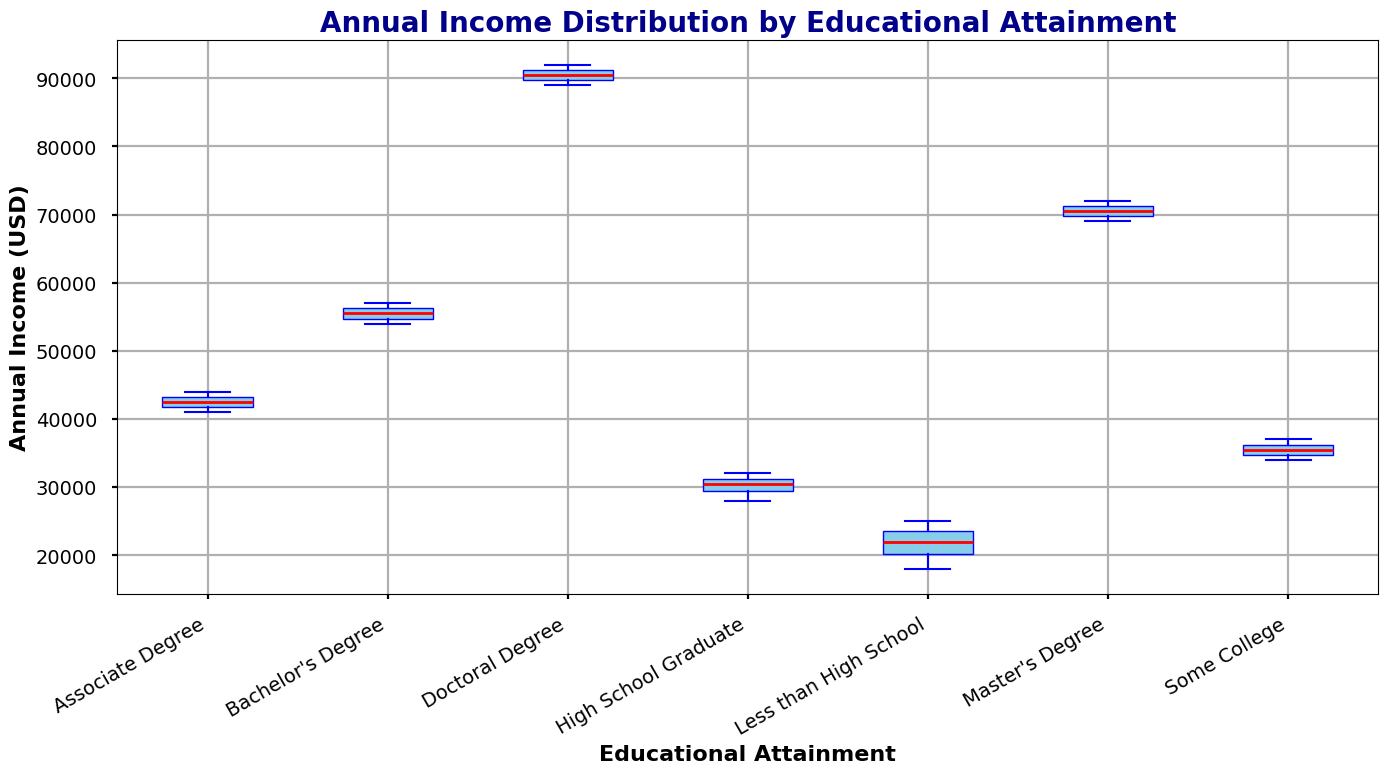What is the median annual income for Bachelor's Degree holders? The red line inside the box plot represents the median. For Bachelor's Degree holders, the line is at 55,000 USD.
Answer: 55,000 USD Which educational attainment level has the highest median annual income? By comparing the red lines (medians) of all box plots, Doctoral Degree holders have the highest median with the red line at 90,000 USD.
Answer: Doctoral Degree How does the median annual income of Associate Degree holders compare to that of High School Graduates? The red line (median) for Associate Degree is at 42,500 USD and for High School Graduate is at 30,500 USD. 42,500 is greater than 30,500.
Answer: Associate Degree is higher What is the interquartile range (IQR) for Some College educational attainment? The IQR is the difference between the upper quartile (75th percentile) and the lower quartile (25th percentile). For Some College, the upper quartile is at 36,500 USD and the lower quartile is at 34,000 USD. Hence, the IQR is 36,500 - 34,000 = 2,500 USD.
Answer: 2,500 USD What does the height of the box in the Master's Degree indicate? The height of the box represents the interquartile range (IQR), which captures the middle 50% of the data. For Master's Degree, the box height shows that the central 50% of incomes are spread across a specific range.
Answer: Interquartile Range (IQR) Are there any outliers in the data for Less than High School educational attainment? Outliers, if present, would be indicated by individual points outside the "whiskers" of the box plot. There are no such points for Less than High School, so there are no outliers.
Answer: No Which educational attainment has the widest range of annual incomes? The range is determined by the difference between the highest and lowest whiskers. Comparing them, the Doctoral Degree has the widest range.
Answer: Doctoral Degree How do the median incomes of High School Graduates and Some College compare? The red line (median) for High School Graduates is at 30,500 USD, and for Some College, it is at 35,500 USD. 35,500 is higher than 30,500.
Answer: Some College is higher Is the median income for Master's Degree holders closer to the upper or lower end of their range? The median is much closer to the lower whisker at 69,000 USD than the upper whisker at 72,000 USD. The red line appears nearer the lower end of the box.
Answer: Lower end Which educational attainment level shows the smallest interquartile range, and what is it? The smallest interquartile range can be found by observing the height of the box plots. The box for Doctoral Degree is the smallest, with a IQR from 89,500 to 91,000 USD, making it 1,500 USD.
Answer: Doctoral Degree, 1,500 USD 